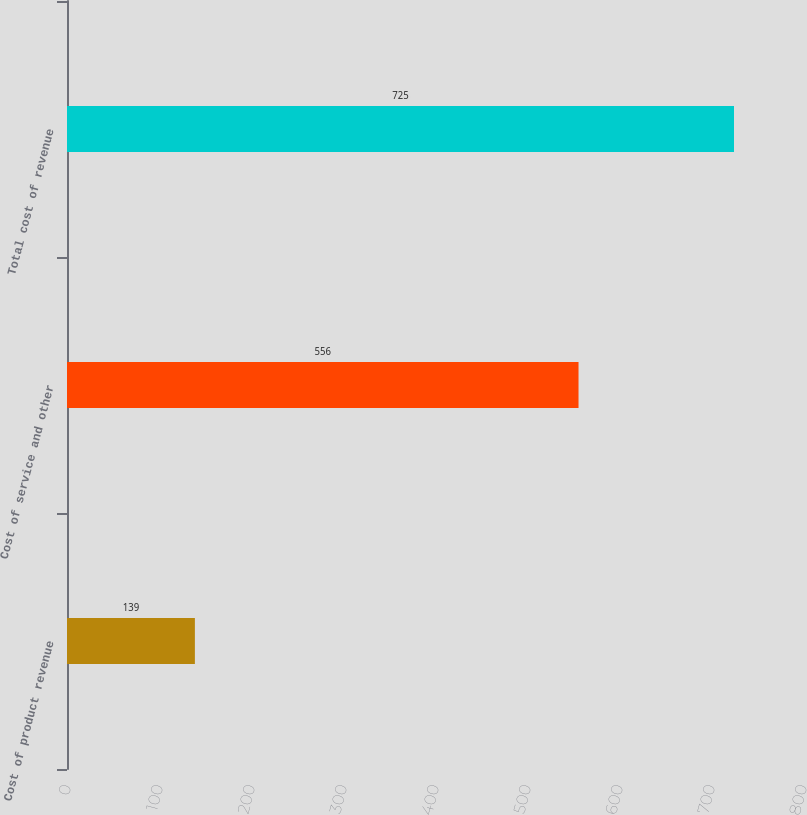<chart> <loc_0><loc_0><loc_500><loc_500><bar_chart><fcel>Cost of product revenue<fcel>Cost of service and other<fcel>Total cost of revenue<nl><fcel>139<fcel>556<fcel>725<nl></chart> 